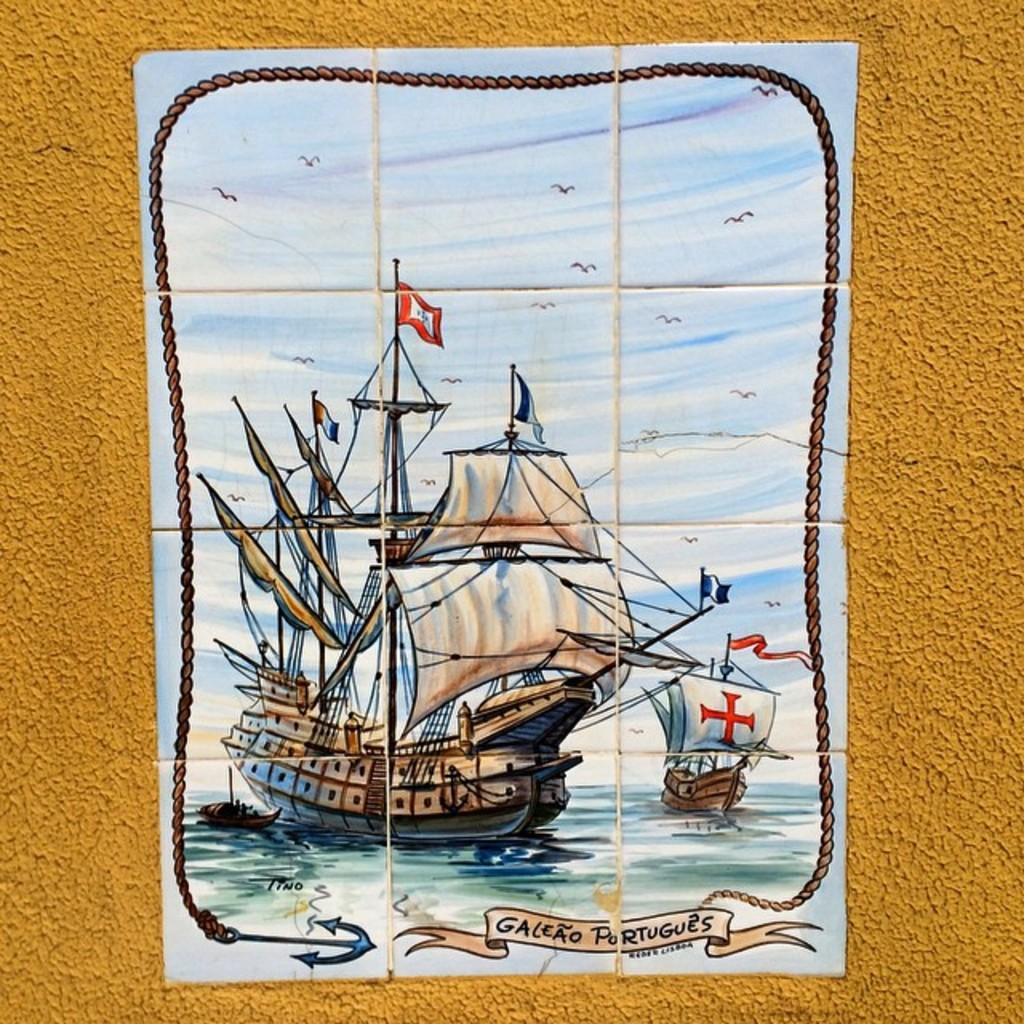What is the main subject of the image? The main subject of the image is a ship poster. Where is the ship poster located in the image? The ship poster is in the center of the image. On what surface is the ship poster placed? The ship poster is placed on a wall. What type of breakfast is being served on the cake in the image? There is no cake or breakfast present in the image; it features a ship poster on a wall. Can you tell me what the mom is doing in the image? There is no mom or any person present in the image; it only shows a ship poster on a wall. 